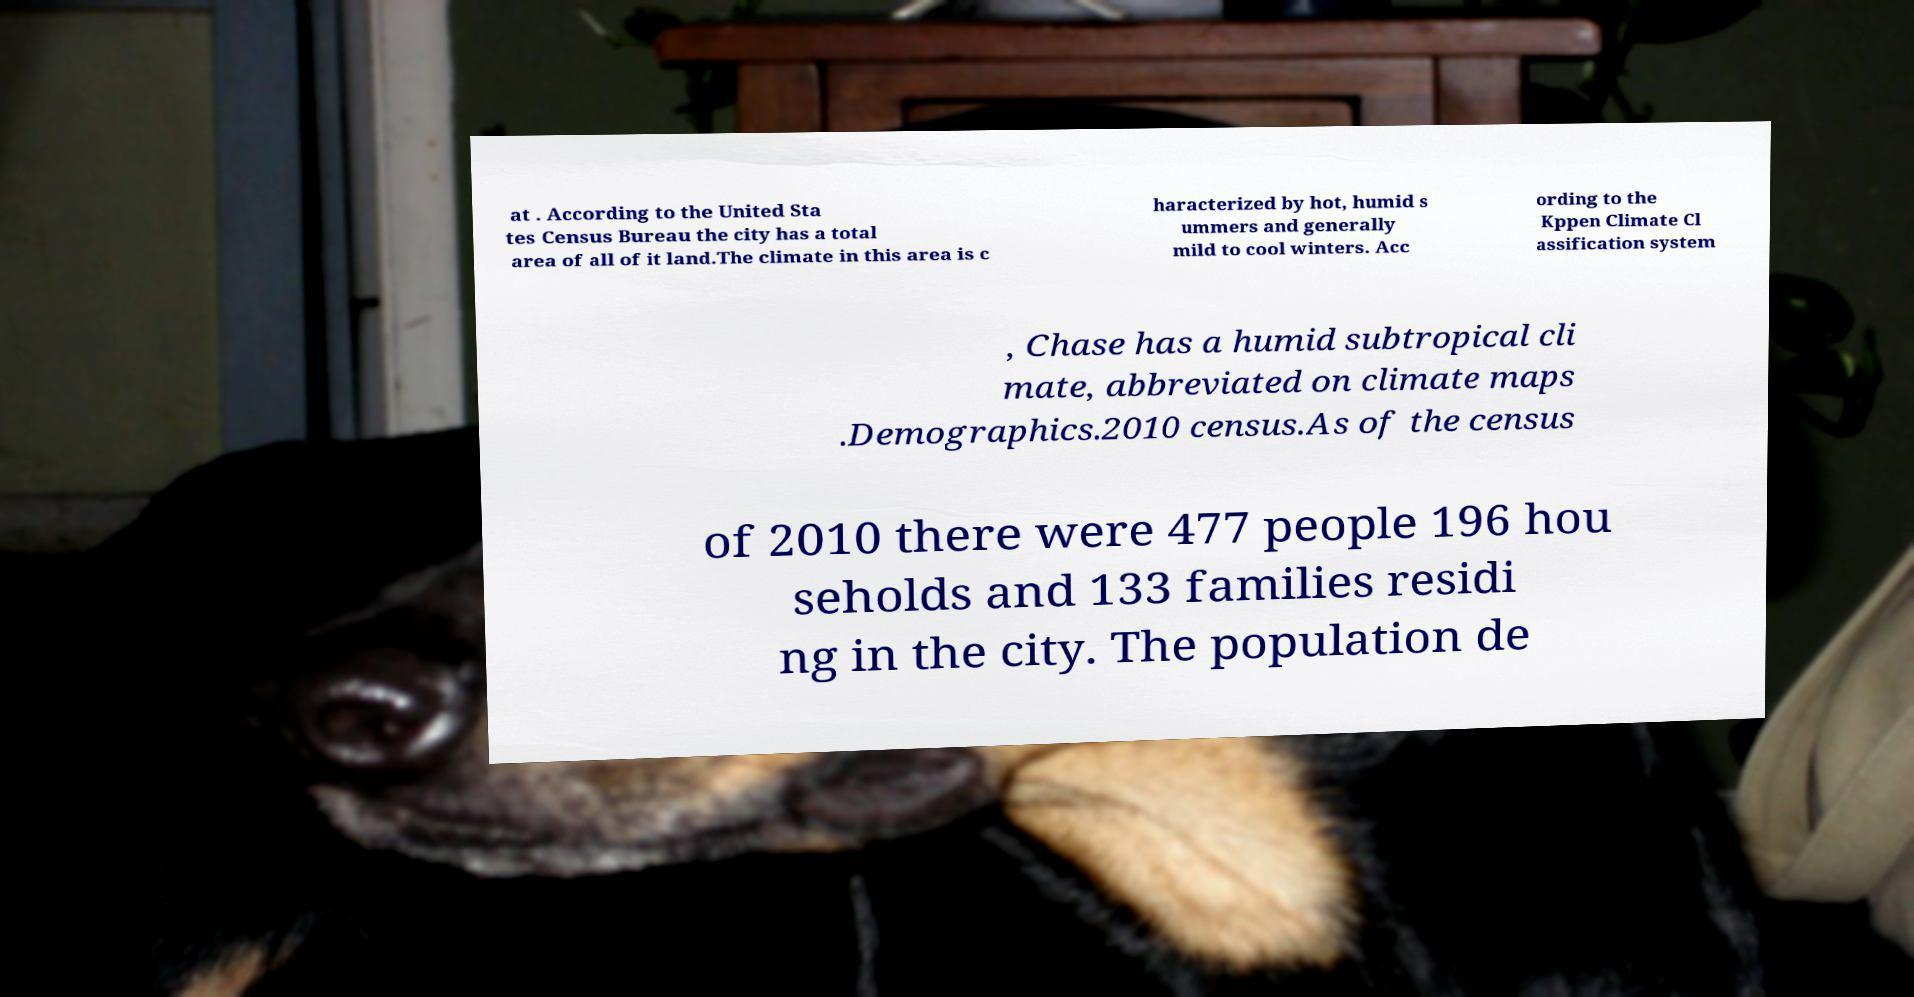What messages or text are displayed in this image? I need them in a readable, typed format. at . According to the United Sta tes Census Bureau the city has a total area of all of it land.The climate in this area is c haracterized by hot, humid s ummers and generally mild to cool winters. Acc ording to the Kppen Climate Cl assification system , Chase has a humid subtropical cli mate, abbreviated on climate maps .Demographics.2010 census.As of the census of 2010 there were 477 people 196 hou seholds and 133 families residi ng in the city. The population de 